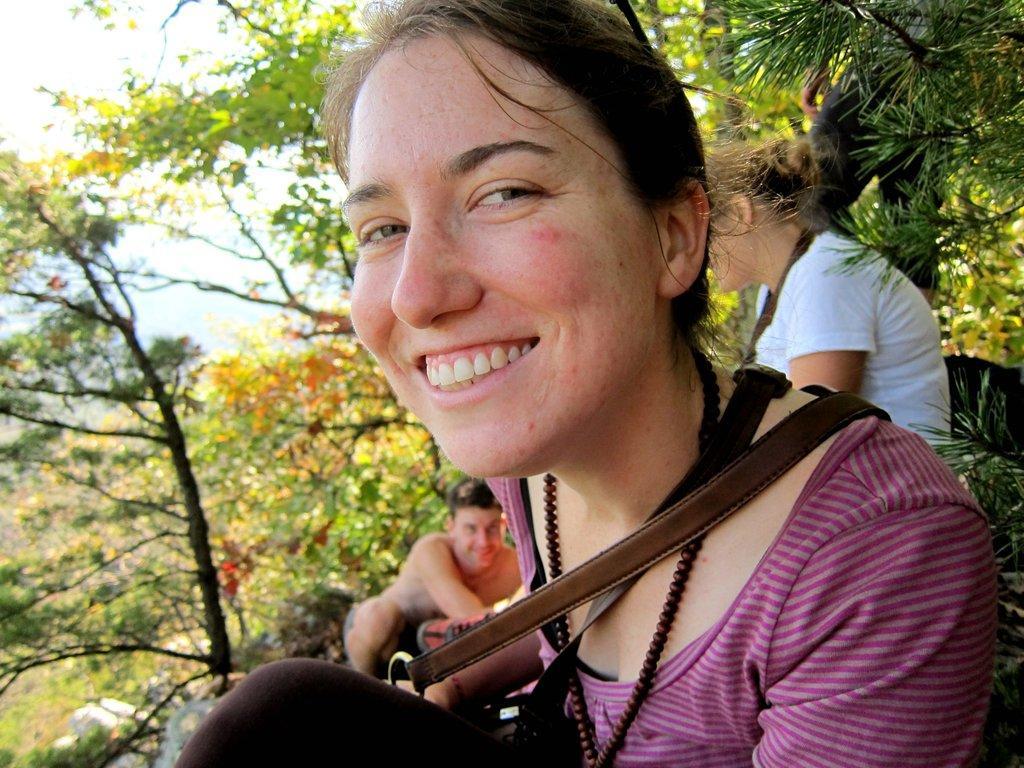Can you describe this image briefly? In this picture I can see few people and some trees. 